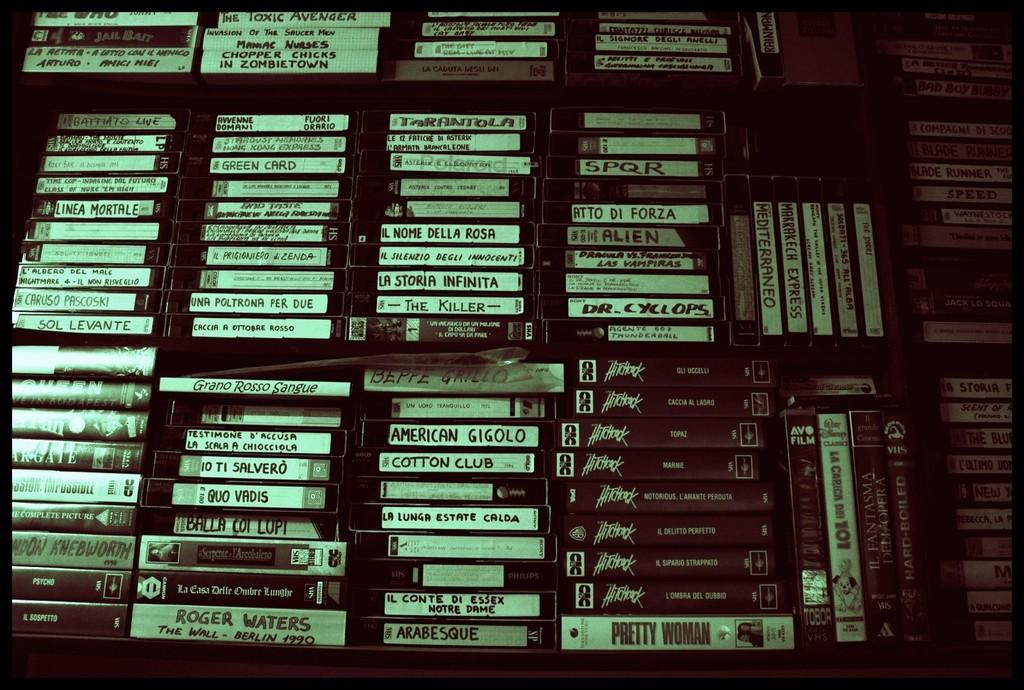<image>
Summarize the visual content of the image. Stacks of VHS tapes such as Pretty Woman and Hitchcock line a wall up to the ceiling. 